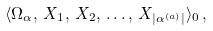Convert formula to latex. <formula><loc_0><loc_0><loc_500><loc_500>\langle \Omega _ { \alpha } , \, X _ { 1 } , \, X _ { 2 } , \, \dots , \, X _ { | \alpha ^ { ( a ) } | } \rangle _ { 0 } \, ,</formula> 